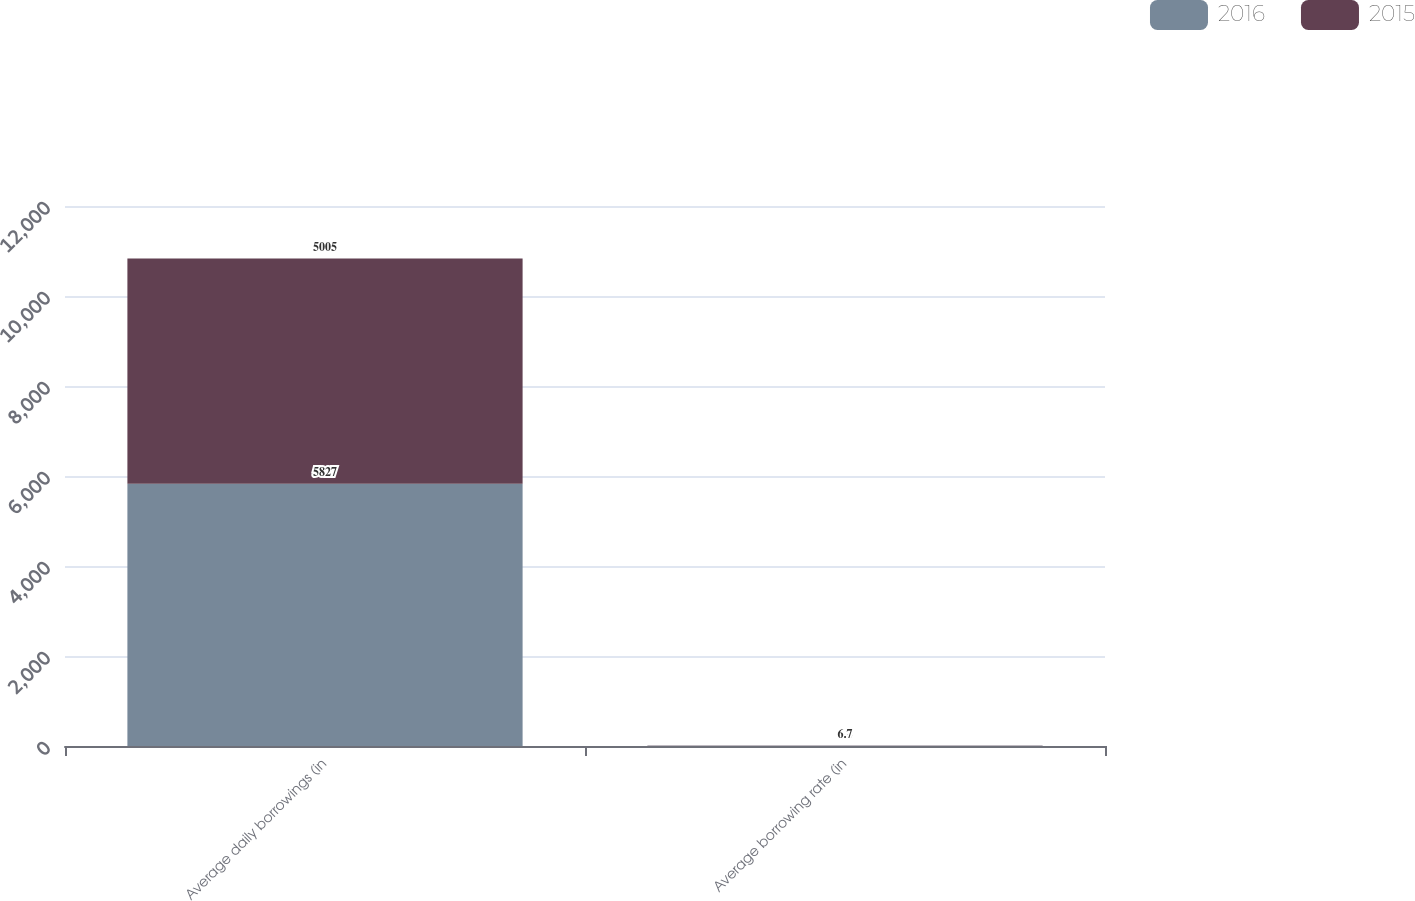Convert chart. <chart><loc_0><loc_0><loc_500><loc_500><stacked_bar_chart><ecel><fcel>Average daily borrowings (in<fcel>Average borrowing rate (in<nl><fcel>2016<fcel>5827<fcel>6.8<nl><fcel>2015<fcel>5005<fcel>6.7<nl></chart> 